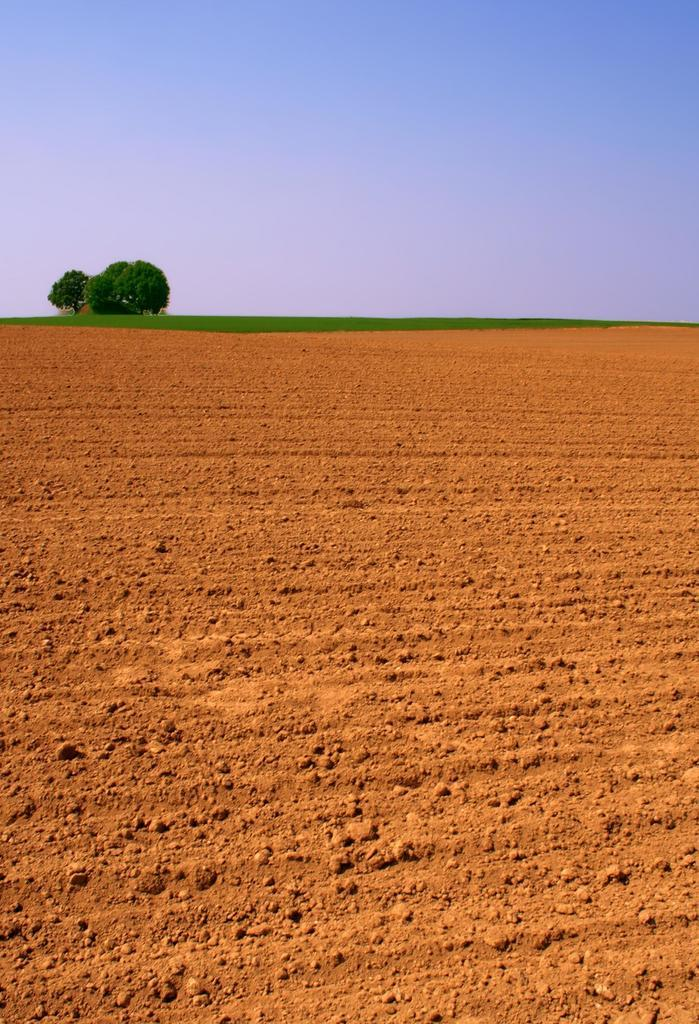What type of terrain is depicted in the image? The image shows a dried land. What objects can be seen on the ground in the image? There are stones visible in the image. What substance is present on the ground in the image? There is mud visible in the image. What type of vegetation can be seen in the background of the image? Plants and trees are present in the background of the image. What is visible in the sky in the background of the image? The sky is visible in the background of the image and appears cloudy. How many children are playing with pies in the image? There are no children or pies present in the image. What type of street can be seen in the image? There is no street visible in the image; it depicts a dried land with stones, mud, and vegetation in the background. 